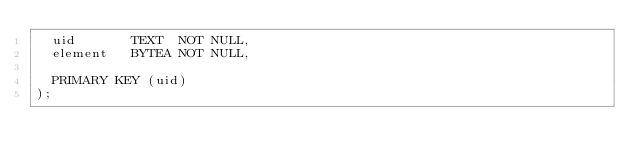Convert code to text. <code><loc_0><loc_0><loc_500><loc_500><_SQL_>  uid       TEXT  NOT NULL,
  element   BYTEA NOT NULL,

  PRIMARY KEY (uid)
);
</code> 